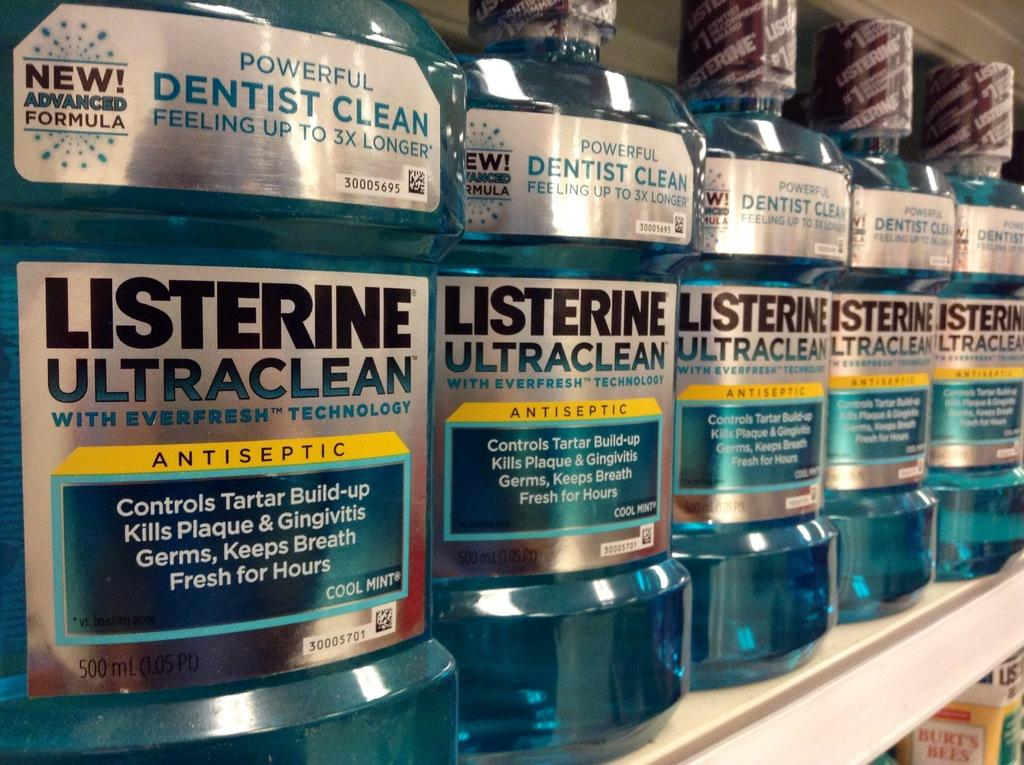What objects are visible in the image? There are bottles in the image. Where are the bottles located? The bottles are on a shelf. What information is provided on the bottles' labels? The bottles have a label that says "listerine ultra clean." What type of celery is growing in the middle of the bottles? There is no celery present in the image; the image only shows bottles on a shelf with a specific label. 